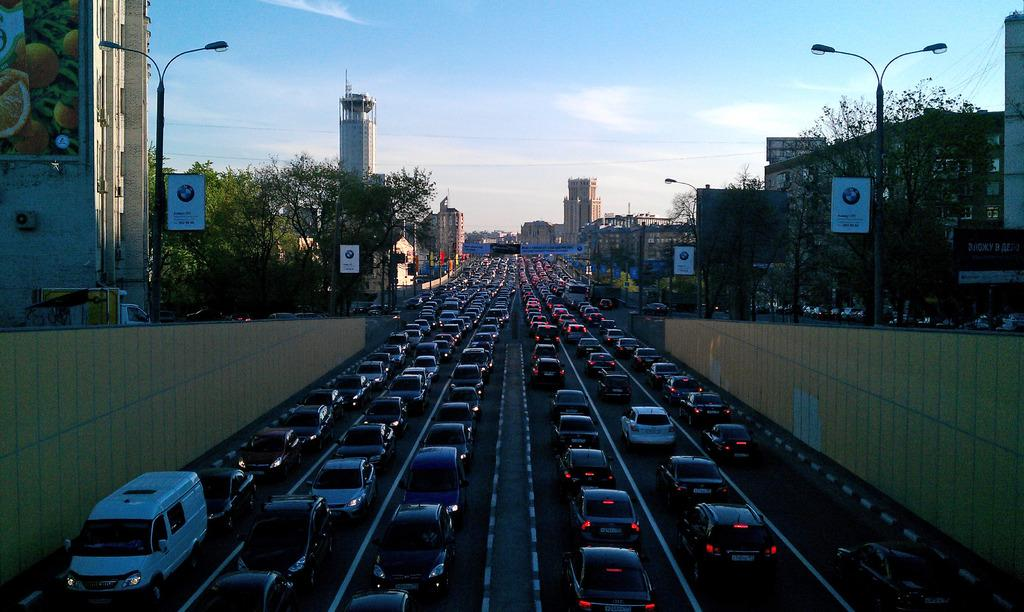What is the main subject of the image? The main subject of the image is many vehicles in the middle of the image. What type of natural elements can be seen in the image? There are trees in the image. What man-made structures are present in the image? There are boards, buildings, and street lamps in the image. What is visible at the top of the image? The sky is visible at the top of the image. Can you see a cub playing with a friend in the image? There is no cub or friend present in the image. What type of protest is happening in the image? There is no protest happening in the image; it features vehicles, trees, boards, buildings, street lamps, and the sky. 